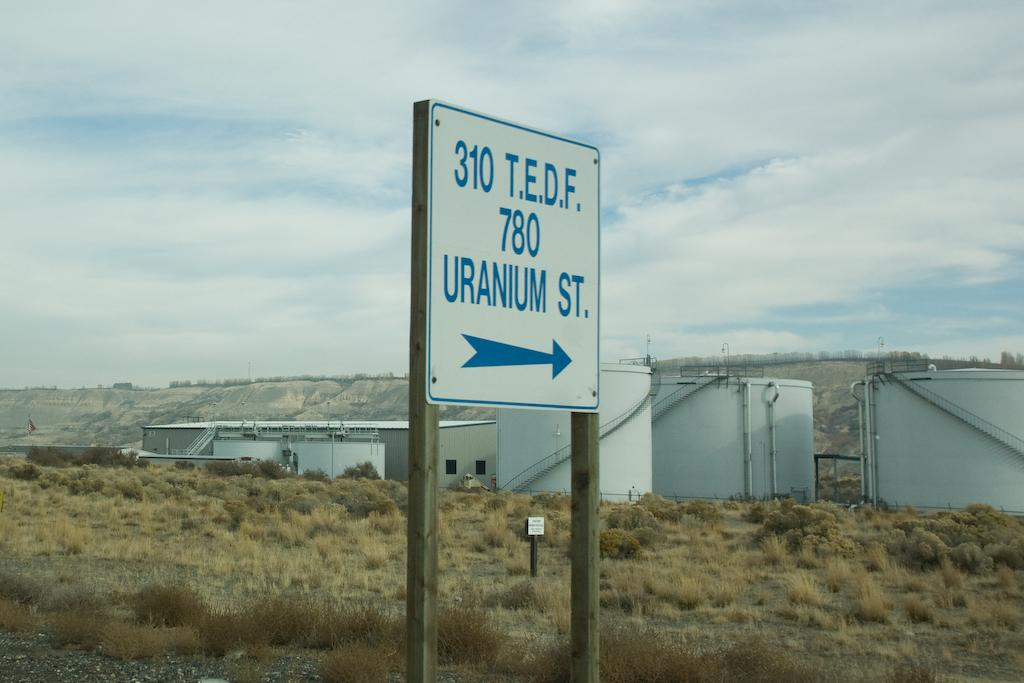<image>
Give a short and clear explanation of the subsequent image. White sign that says "Uranium St." on it. 